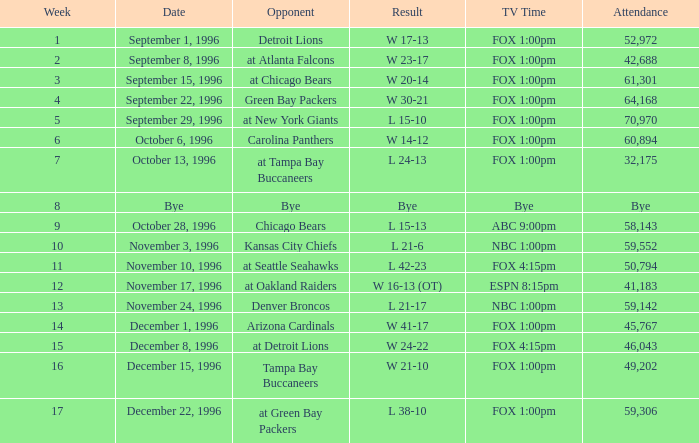Tell me the opponent for november 24, 1996 Denver Broncos. 